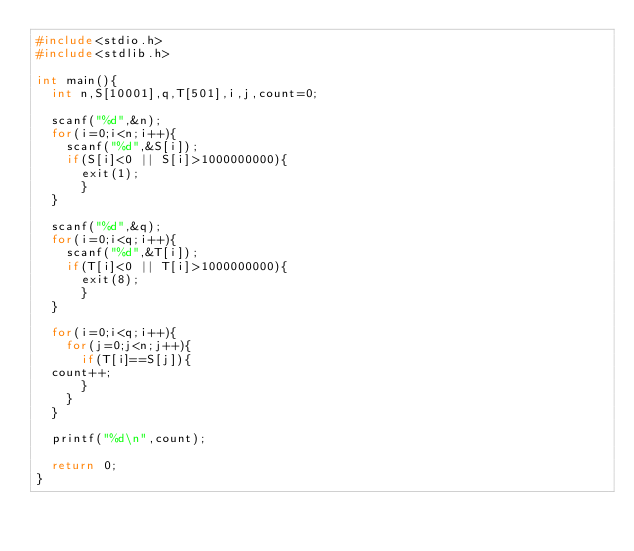Convert code to text. <code><loc_0><loc_0><loc_500><loc_500><_C_>#include<stdio.h>
#include<stdlib.h>

int main(){
  int n,S[10001],q,T[501],i,j,count=0;

  scanf("%d",&n);
  for(i=0;i<n;i++){
    scanf("%d",&S[i]);
    if(S[i]<0 || S[i]>1000000000){
      exit(1);
      }
  }

  scanf("%d",&q);
  for(i=0;i<q;i++){
    scanf("%d",&T[i]);
    if(T[i]<0 || T[i]>1000000000){
      exit(8);
      }
  }
  
  for(i=0;i<q;i++){
    for(j=0;j<n;j++){
      if(T[i]==S[j]){
	count++;
      }
    }
  }
  
  printf("%d\n",count);

  return 0;
}</code> 